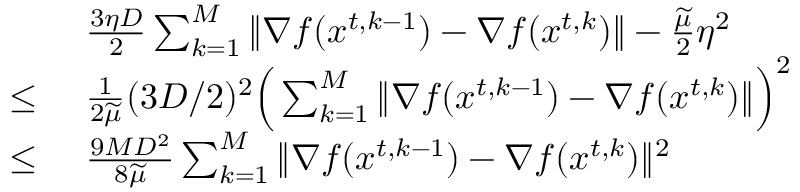Convert formula to latex. <formula><loc_0><loc_0><loc_500><loc_500>\begin{array} { r l } & { \frac { 3 \eta D } { 2 } \sum _ { k = 1 } ^ { M } \| \nabla f ( { x } ^ { t , k - 1 } ) - \nabla f ( { x } ^ { t , k } ) \| - \frac { \widetilde { \mu } } { 2 } \eta ^ { 2 } } \\ { \leq \ } & { \frac { 1 } { 2 \widetilde { \mu } } ( 3 D / 2 ) ^ { 2 } \left ( \sum _ { k = 1 } ^ { M } \| \nabla f ( { x } ^ { t , k - 1 } ) - \nabla f ( { x } ^ { t , k } ) \| \right ) ^ { 2 } } \\ { \leq \ } & { \frac { 9 M D ^ { 2 } } { 8 \widetilde { \mu } } \sum _ { k = 1 } ^ { M } \| \nabla f ( { x } ^ { t , k - 1 } ) - \nabla f ( { x } ^ { t , k } ) \| ^ { 2 } } \end{array}</formula> 